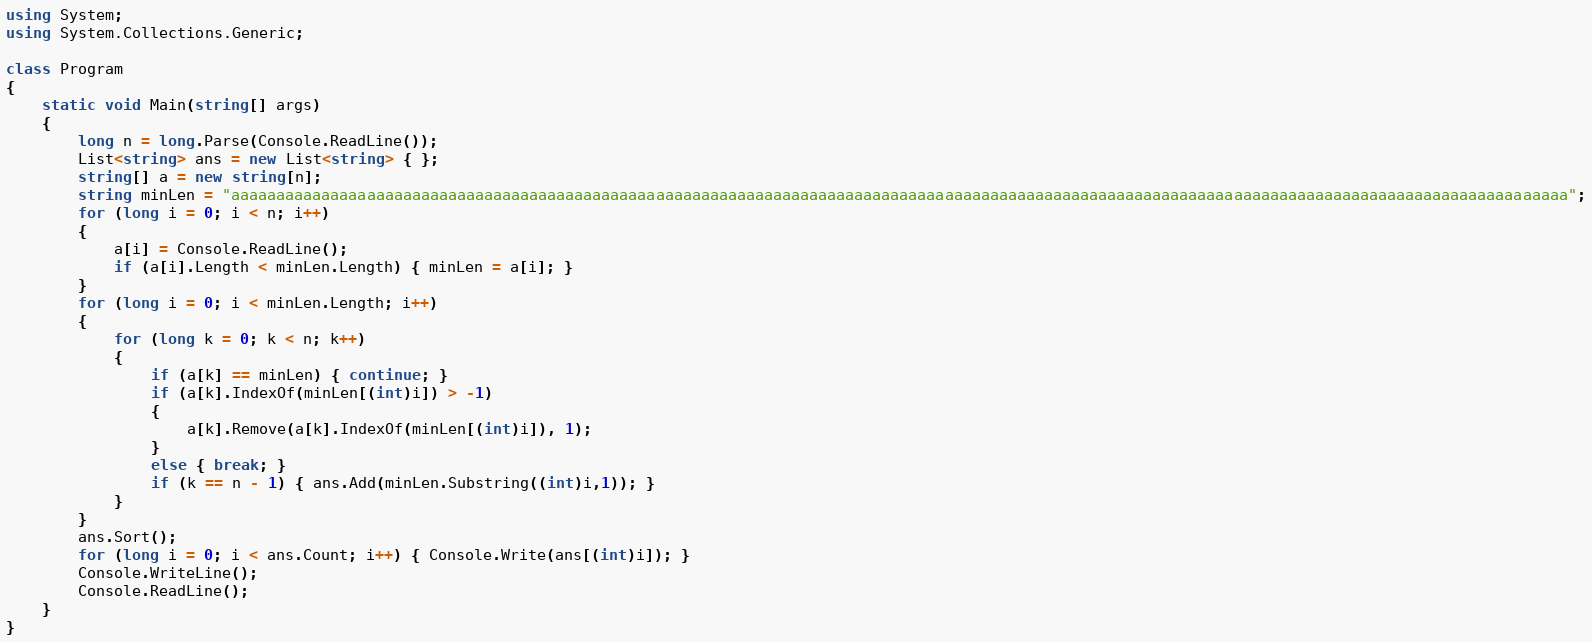<code> <loc_0><loc_0><loc_500><loc_500><_C#_>using System;
using System.Collections.Generic;

class Program
{
    static void Main(string[] args)
    {
        long n = long.Parse(Console.ReadLine());
        List<string> ans = new List<string> { };
        string[] a = new string[n];
        string minLen = "aaaaaaaaaaaaaaaaaaaaaaaaaaaaaaaaaaaaaaaaaaaaaaaaaaaaaaaaaaaaaaaaaaaaaaaaaaaaaaaaaaaaaaaaaaaaaaaaaaaaaaaaaaaaaaaaaaaaaaaaaaaaaaaaaaaaaaaaaaaaaaaaaaaa";
        for (long i = 0; i < n; i++)
        {
            a[i] = Console.ReadLine();
            if (a[i].Length < minLen.Length) { minLen = a[i]; }
        }
        for (long i = 0; i < minLen.Length; i++)
        {
            for (long k = 0; k < n; k++)
            {
                if (a[k] == minLen) { continue; }
                if (a[k].IndexOf(minLen[(int)i]) > -1)
                {
                    a[k].Remove(a[k].IndexOf(minLen[(int)i]), 1);
                }
                else { break; }
                if (k == n - 1) { ans.Add(minLen.Substring((int)i,1)); }
            }
        }
        ans.Sort();
        for (long i = 0; i < ans.Count; i++) { Console.Write(ans[(int)i]); }
        Console.WriteLine();
        Console.ReadLine();
    }
}

</code> 